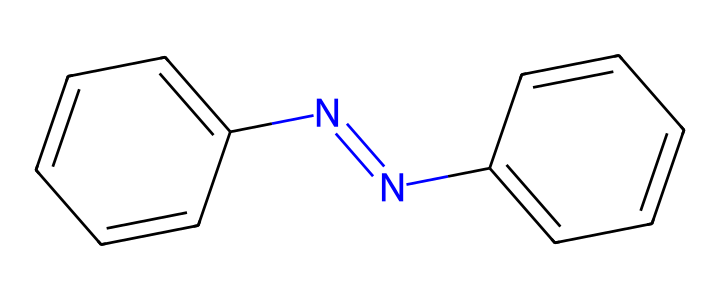How many total carbon atoms are in azobenzene? The SMILES representation contains two aromatic rings, each with six carbon atoms. Since there are no additional carbon atoms, the total comes to 12.
Answer: 12 What is the total number of nitrogen atoms present in azobenzene? By examining the SMILES representation, we can see there is one nitrogen atom in the azo group (-N=N-), indicating there are 2 nitrogen atoms in total.
Answer: 2 What type of chemical bond is indicated by the "N=N" portion? The "N=N" in the SMILES structure represents a double bond between nitrogen atoms, characteristic of azo compounds, which is crucial for their photoreactivity.
Answer: double bond Which part of azobenzene is responsible for its photoisomerization? The azo group (the "N=N" part) is responsible for the property of photoisomerization, meaning it can change structure when exposed to UV light, altering its physical properties.
Answer: azo group What is the significance of using azobenzene in UV-protective tennis clothing? Azobenzene absorbs UV light, which allows it to provide protective qualities to the tennis clothing by preventing harmful UV radiation from penetrating the fabric.
Answer: UV absorption What is the molecular formula of azobenzene? From counting atoms represented in the SMILES, we find 12 carbon (C), 10 hydrogen (H), and 2 nitrogen (N) atoms, combining to form the molecular formula C12H10N2.
Answer: C12H10N2 